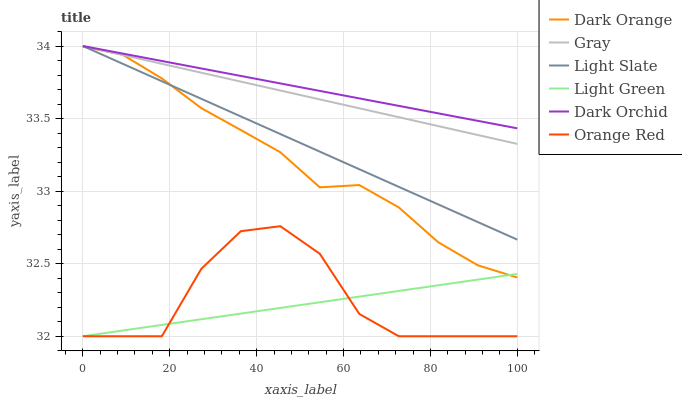Does Light Green have the minimum area under the curve?
Answer yes or no. Yes. Does Dark Orchid have the maximum area under the curve?
Answer yes or no. Yes. Does Gray have the minimum area under the curve?
Answer yes or no. No. Does Gray have the maximum area under the curve?
Answer yes or no. No. Is Light Slate the smoothest?
Answer yes or no. Yes. Is Orange Red the roughest?
Answer yes or no. Yes. Is Gray the smoothest?
Answer yes or no. No. Is Gray the roughest?
Answer yes or no. No. Does Light Green have the lowest value?
Answer yes or no. Yes. Does Gray have the lowest value?
Answer yes or no. No. Does Dark Orchid have the highest value?
Answer yes or no. Yes. Does Light Green have the highest value?
Answer yes or no. No. Is Orange Red less than Dark Orchid?
Answer yes or no. Yes. Is Light Slate greater than Orange Red?
Answer yes or no. Yes. Does Dark Orchid intersect Gray?
Answer yes or no. Yes. Is Dark Orchid less than Gray?
Answer yes or no. No. Is Dark Orchid greater than Gray?
Answer yes or no. No. Does Orange Red intersect Dark Orchid?
Answer yes or no. No. 